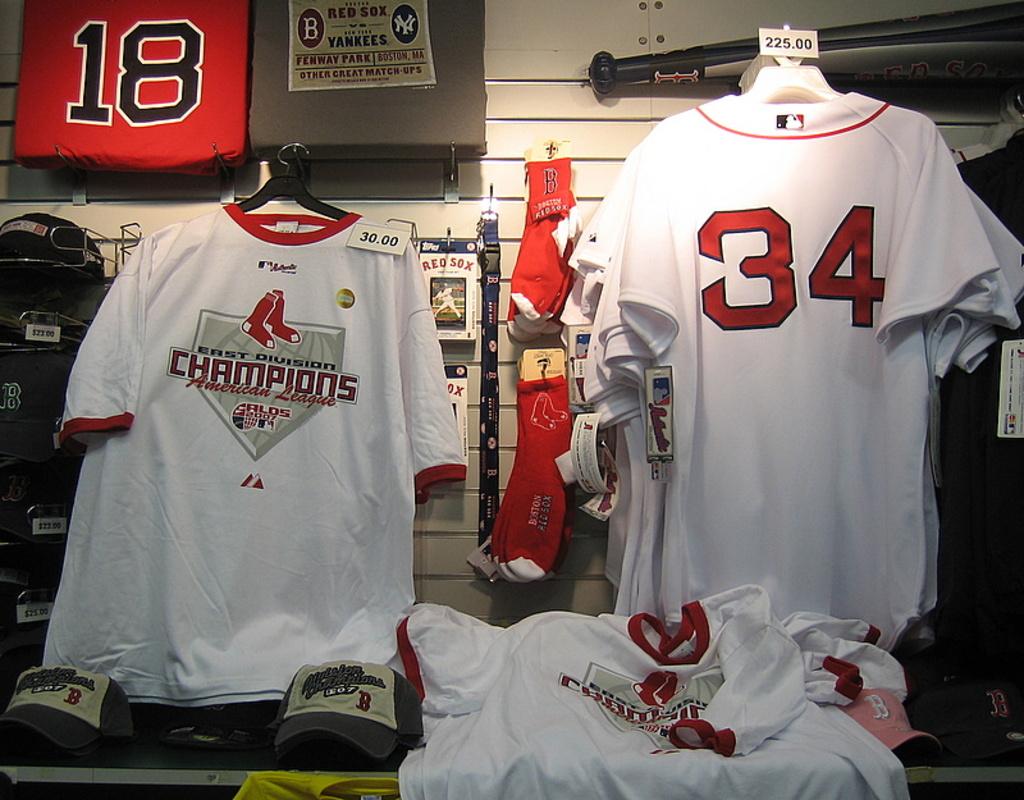Do the shirts say east division champions on them?
Ensure brevity in your answer.  Yes. 